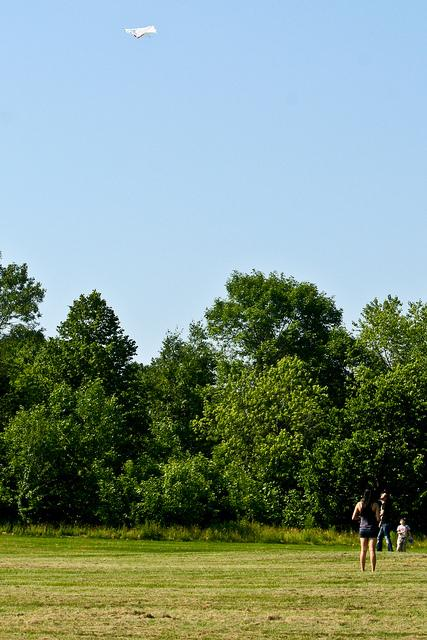What are the people standing in front of?

Choices:
A) cats
B) trees
C) book shelves
D) apples trees 